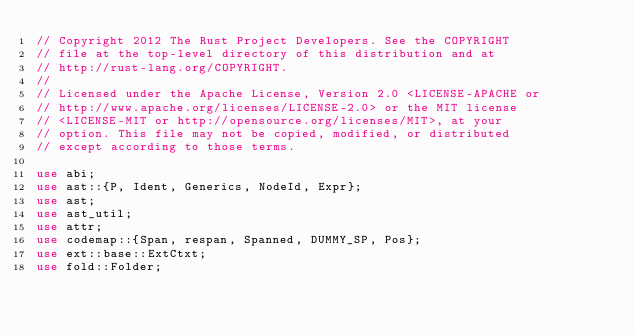<code> <loc_0><loc_0><loc_500><loc_500><_Rust_>// Copyright 2012 The Rust Project Developers. See the COPYRIGHT
// file at the top-level directory of this distribution and at
// http://rust-lang.org/COPYRIGHT.
//
// Licensed under the Apache License, Version 2.0 <LICENSE-APACHE or
// http://www.apache.org/licenses/LICENSE-2.0> or the MIT license
// <LICENSE-MIT or http://opensource.org/licenses/MIT>, at your
// option. This file may not be copied, modified, or distributed
// except according to those terms.

use abi;
use ast::{P, Ident, Generics, NodeId, Expr};
use ast;
use ast_util;
use attr;
use codemap::{Span, respan, Spanned, DUMMY_SP, Pos};
use ext::base::ExtCtxt;
use fold::Folder;</code> 